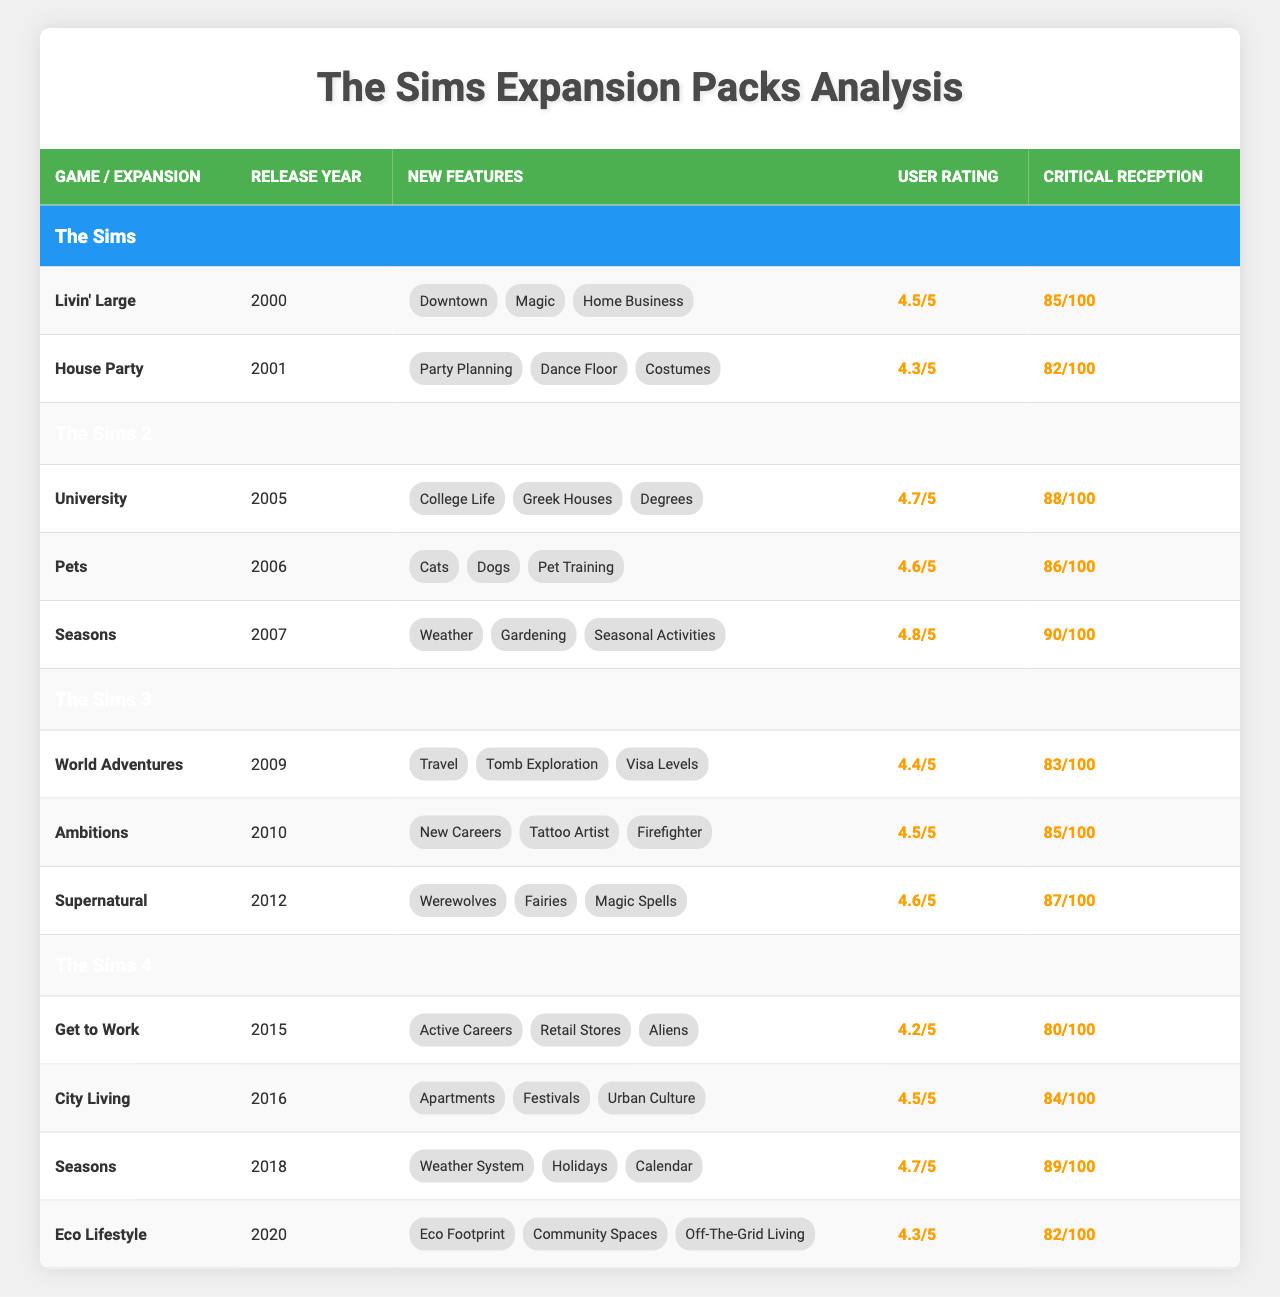What is the highest user rating among all expansion packs? The user ratings are 4.8 for "Seasons" in "The Sims 2". This is the maximum value in the User Rating column when compared across all expansion packs.
Answer: 4.8 Which expansion pack was released first, "Livin' Large" or "Pets"? "Livin' Large" was released in 2000, while "Pets" was released in 2006. Since 2000 is earlier than 2006, "Livin' Large" was released first.
Answer: Livin' Large What is the average critical reception score of expansion packs in "The Sims 4"? The critical reception scores for "Get to Work" (80), "City Living" (84), "Seasons" (89), and "Eco Lifestyle" (82) sum up to 335. Dividing by the number of expansion packs (4) gives an average of 335/4 = 83.75, which rounds to 84.
Answer: 84 Did "University" have a higher user rating than "Get to Work"? "University" has a user rating of 4.7, while "Get to Work" has a user rating of 4.2. Since 4.7 is greater than 4.2, the statement is true.
Answer: Yes Which game has more expansion packs listed, "The Sims" or "The Sims 3"? "The Sims" has 2 expansion packs (Livin' Large, House Party), while "The Sims 3" has 3 expansion packs (World Adventures, Ambitions, Supernatural). Comparing the counts, "The Sims 3" has more.
Answer: The Sims 3 What are the new features introduced in the "Eco Lifestyle" expansion pack? The new features of the "Eco Lifestyle" expansion pack include "Eco Footprint", "Community Spaces", and "Off-The-Grid Living". These features can be found listed under the corresponding expansion in the table.
Answer: Eco Footprint, Community Spaces, Off-The-Grid Living Which expansion pack has the lowest critical reception score? Among all expansion packs, "Get to Work" has the lowest critical reception score of 80, the sole score below 82.
Answer: 80 How many expansion packs have a user rating of 4.6 or above? The user ratings of expansion packs that are 4.6 or above are: "Livin' Large" (4.5), "University" (4.7), "Pets" (4.6), "Seasons" (4.8), "Ambitions" (4.5), "Supernatural" (4.6), "City Living" (4.5), and "Seasons" (4.7). Counting these gives us a total of 7 expansion packs.
Answer: 7 Is it true that all expansion packs for "The Sims 2" have user ratings above 4.5? The user ratings for "University" (4.7), "Pets" (4.6), and "Seasons" (4.8) are all above 4.5. So, yes, it is true that they all have user ratings above 4.5.
Answer: Yes 